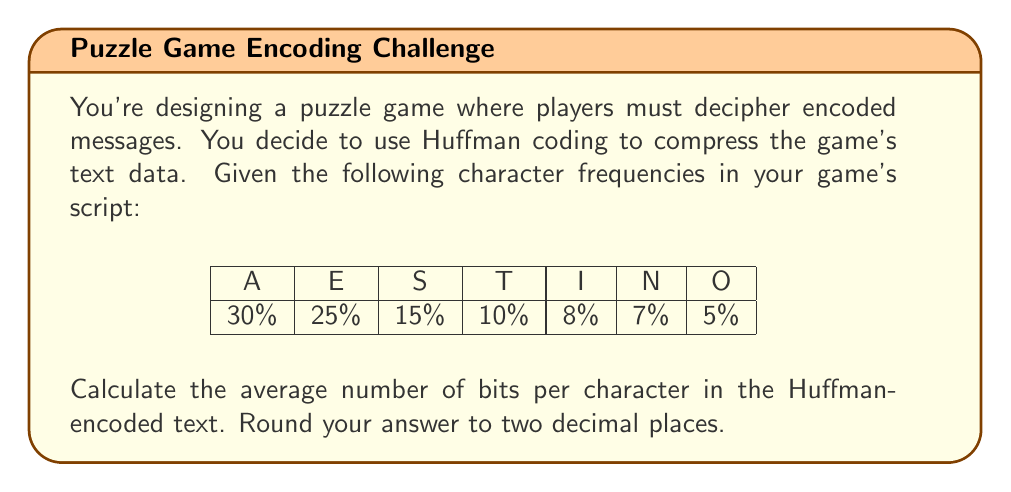Help me with this question. To solve this problem, we'll follow these steps:

1) Construct the Huffman tree
2) Determine the Huffman code for each character
3) Calculate the average number of bits per character

Step 1: Constructing the Huffman tree

We start with leaf nodes for each character, ordered by frequency:
O(5%), N(7%), I(8%), T(10%), S(15%), E(25%), A(30%)

We iteratively combine the two least frequent nodes:

1. O(5%) + N(7%) = ON(12%)
2. I(8%) + ON(12%) = ION(20%)
3. T(10%) + S(15%) = TS(25%)
4. E(25%) + TS(25%) = ETS(50%)
5. A(30%) + ION(20%) = AION(50%)
6. ETS(50%) + AION(50%) = ETAIONS(100%)

Step 2: Determining Huffman codes

Traversing the tree, assigning 0 to left branches and 1 to right branches:

A: 00
E: 10
S: 110
T: 111
I: 010
N: 0110
O: 0111

Step 3: Calculating average bits per character

We multiply each character's frequency by its code length:

$$
\begin{align*}
A: 30\% \times 2 &= 0.60 \\
E: 25\% \times 2 &= 0.50 \\
S: 15\% \times 3 &= 0.45 \\
T: 10\% \times 3 &= 0.30 \\
I: 8\% \times 3 &= 0.24 \\
N: 7\% \times 4 &= 0.28 \\
O: 5\% \times 4 &= 0.20 \\
\end{align*}
$$

Sum these values:

$$ 0.60 + 0.50 + 0.45 + 0.30 + 0.24 + 0.28 + 0.20 = 2.57 $$

Therefore, the average number of bits per character is 2.57.
Answer: 2.57 bits per character 